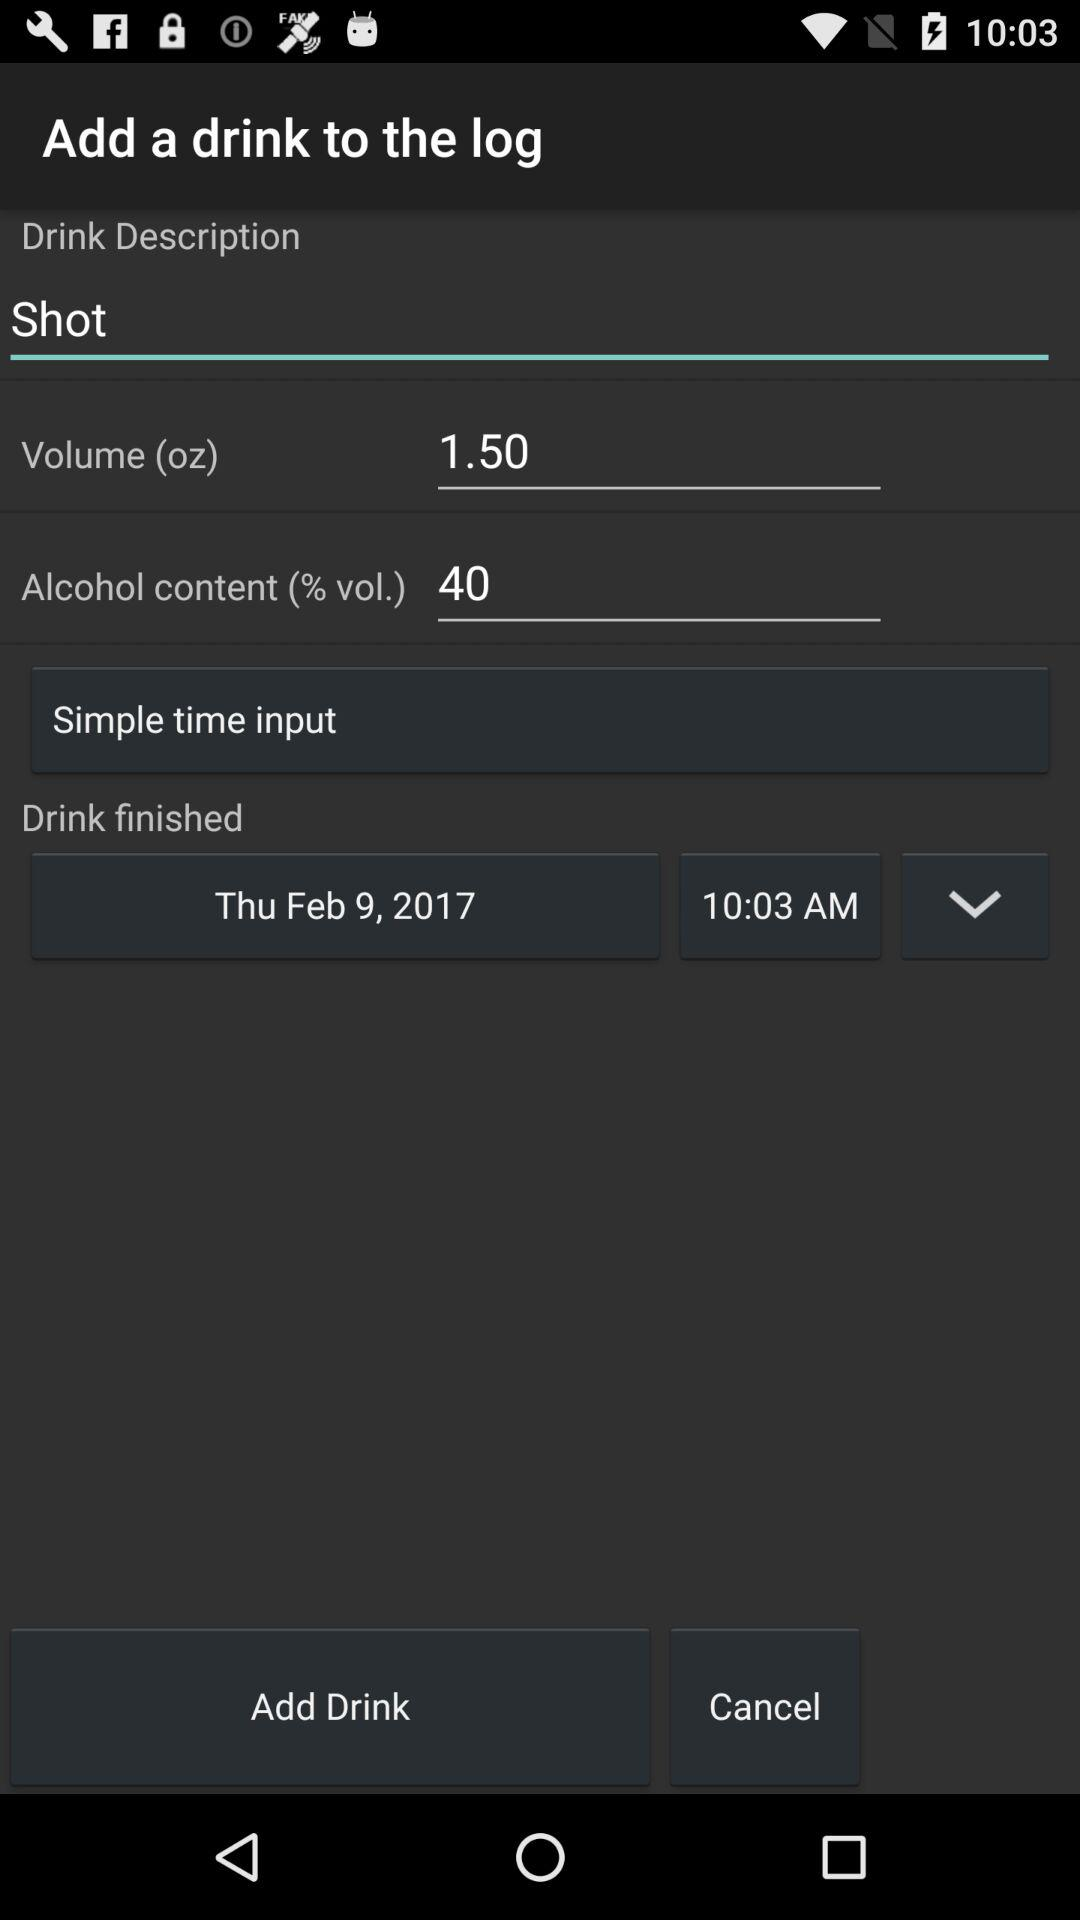What is the mentioned time? The mentioned time is 10:03 AM. 